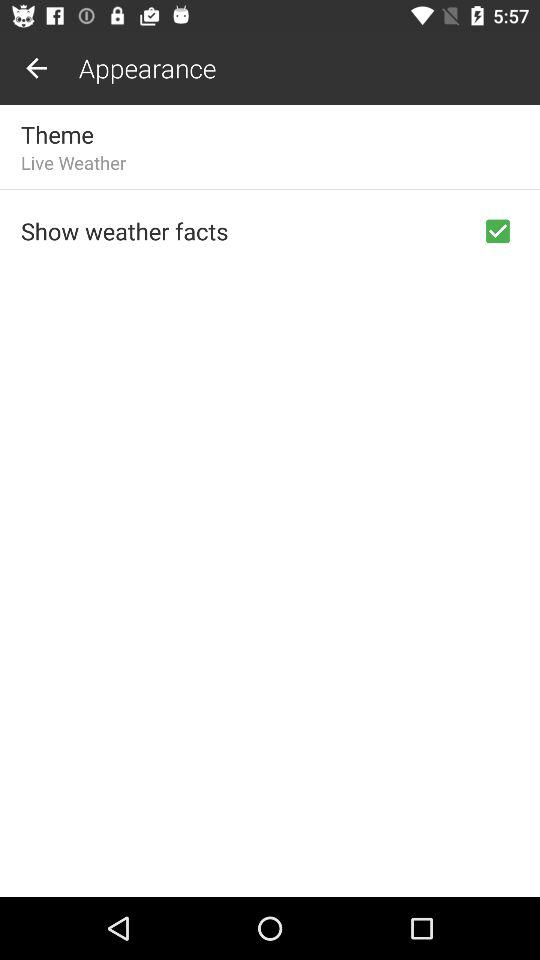What is the status of "Show weather facts"? The status is "on". 